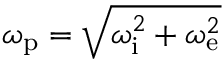Convert formula to latex. <formula><loc_0><loc_0><loc_500><loc_500>\omega _ { p } = \sqrt { \omega _ { i } ^ { 2 } + \omega _ { e } ^ { 2 } }</formula> 